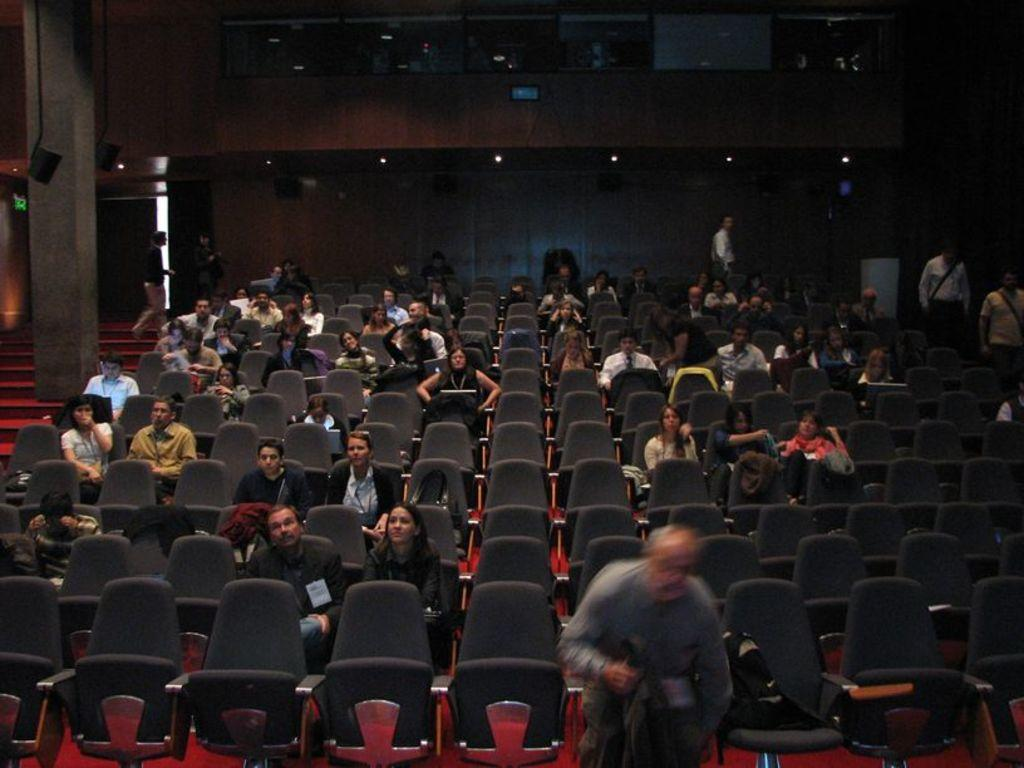How many people are in the image? There is a group of people in the image. What are the people in the image doing? The people are sitting. What architectural feature can be seen in the image? There are stairs visible in the image. What can be seen in the background of the image? There are lights in the background of the image. What type of watch is the person wearing in the image? There is no watch visible on any person in the image. How does the lift function in the image? There is no lift present in the image. 